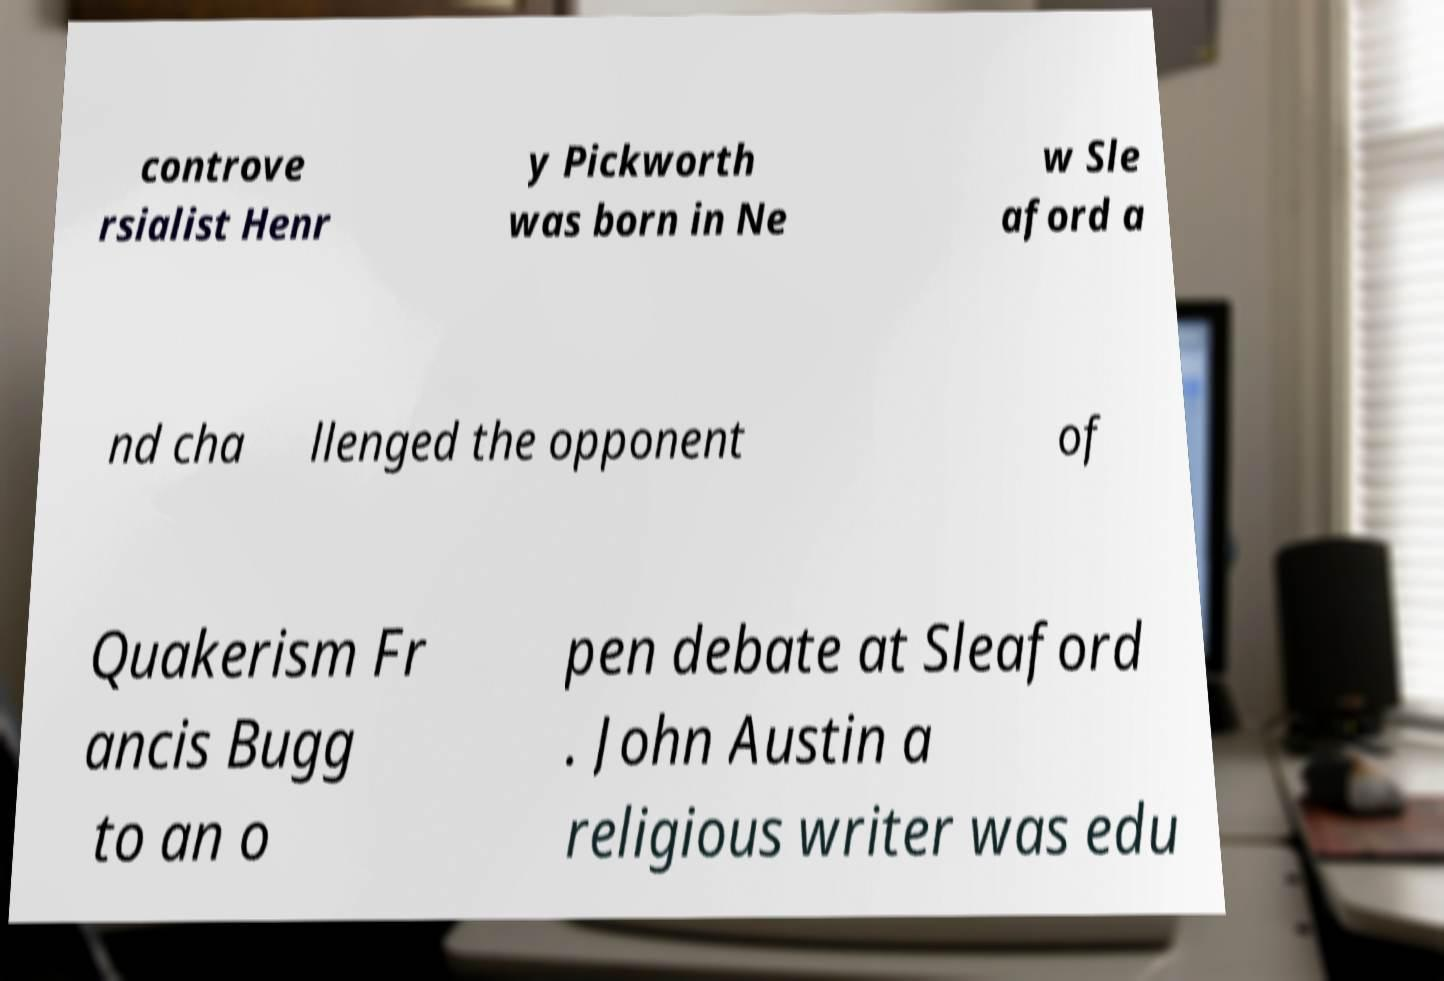Could you assist in decoding the text presented in this image and type it out clearly? controve rsialist Henr y Pickworth was born in Ne w Sle aford a nd cha llenged the opponent of Quakerism Fr ancis Bugg to an o pen debate at Sleaford . John Austin a religious writer was edu 